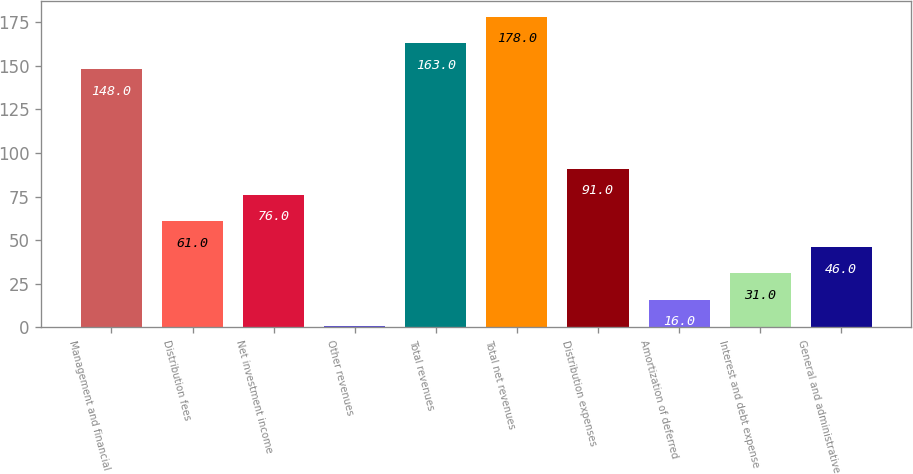<chart> <loc_0><loc_0><loc_500><loc_500><bar_chart><fcel>Management and financial<fcel>Distribution fees<fcel>Net investment income<fcel>Other revenues<fcel>Total revenues<fcel>Total net revenues<fcel>Distribution expenses<fcel>Amortization of deferred<fcel>Interest and debt expense<fcel>General and administrative<nl><fcel>148<fcel>61<fcel>76<fcel>1<fcel>163<fcel>178<fcel>91<fcel>16<fcel>31<fcel>46<nl></chart> 